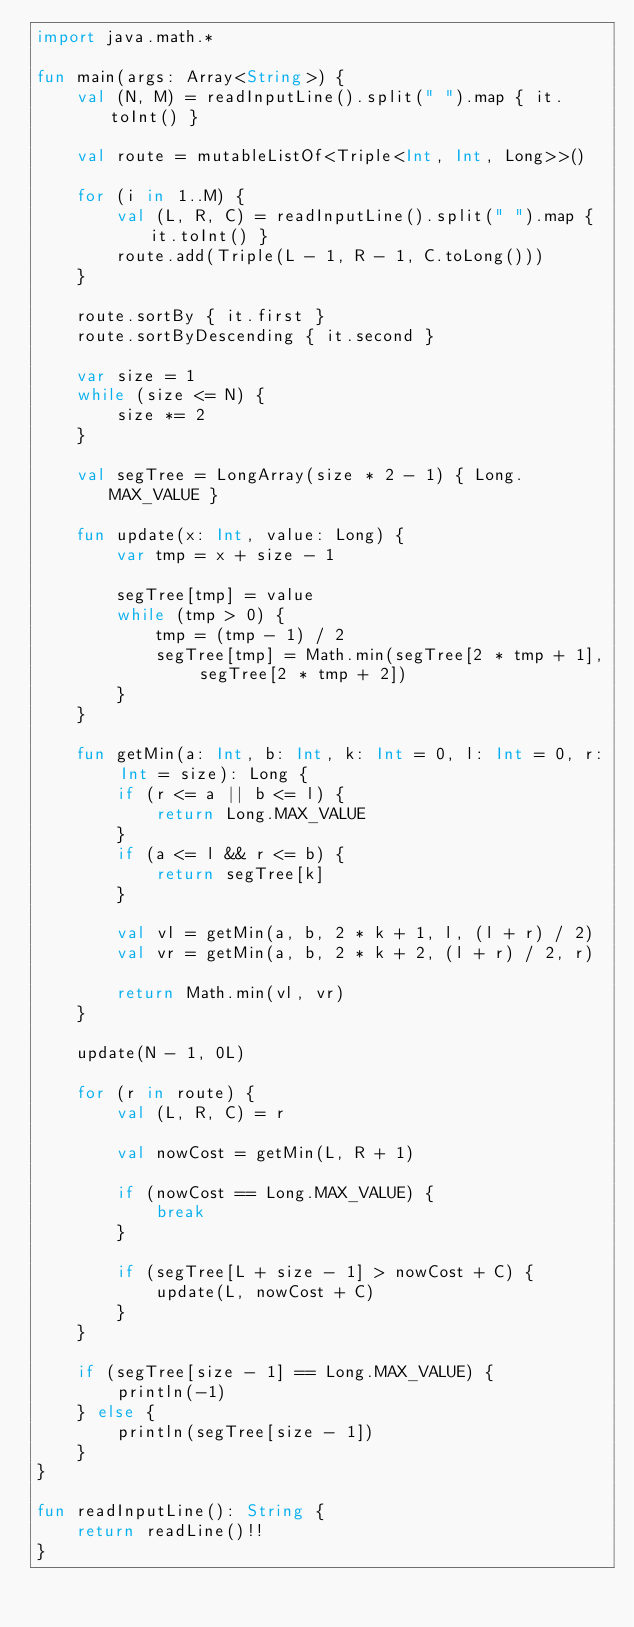<code> <loc_0><loc_0><loc_500><loc_500><_Kotlin_>import java.math.*

fun main(args: Array<String>) {
    val (N, M) = readInputLine().split(" ").map { it.toInt() }
    
    val route = mutableListOf<Triple<Int, Int, Long>>()
    
    for (i in 1..M) {
        val (L, R, C) = readInputLine().split(" ").map { it.toInt() }
        route.add(Triple(L - 1, R - 1, C.toLong()))
    }
    
    route.sortBy { it.first }
    route.sortByDescending { it.second }
    
    var size = 1
    while (size <= N) {
        size *= 2
    }
    
    val segTree = LongArray(size * 2 - 1) { Long.MAX_VALUE }
    
    fun update(x: Int, value: Long) {
        var tmp = x + size - 1
        
        segTree[tmp] = value
        while (tmp > 0) {
            tmp = (tmp - 1) / 2
            segTree[tmp] = Math.min(segTree[2 * tmp + 1], segTree[2 * tmp + 2])
        }
    }
    
    fun getMin(a: Int, b: Int, k: Int = 0, l: Int = 0, r: Int = size): Long {
        if (r <= a || b <= l) {
            return Long.MAX_VALUE
        }
        if (a <= l && r <= b) {
            return segTree[k]
        }
        
        val vl = getMin(a, b, 2 * k + 1, l, (l + r) / 2)
        val vr = getMin(a, b, 2 * k + 2, (l + r) / 2, r)
        
        return Math.min(vl, vr)
    }
    
    update(N - 1, 0L)

    for (r in route) {
        val (L, R, C) = r

        val nowCost = getMin(L, R + 1)
        
        if (nowCost == Long.MAX_VALUE) {
            break
        }

        if (segTree[L + size - 1] > nowCost + C) {
            update(L, nowCost + C)
        }
    }

    if (segTree[size - 1] == Long.MAX_VALUE) {
        println(-1)
    } else {
        println(segTree[size - 1])
    }
}

fun readInputLine(): String {
    return readLine()!!
}
</code> 